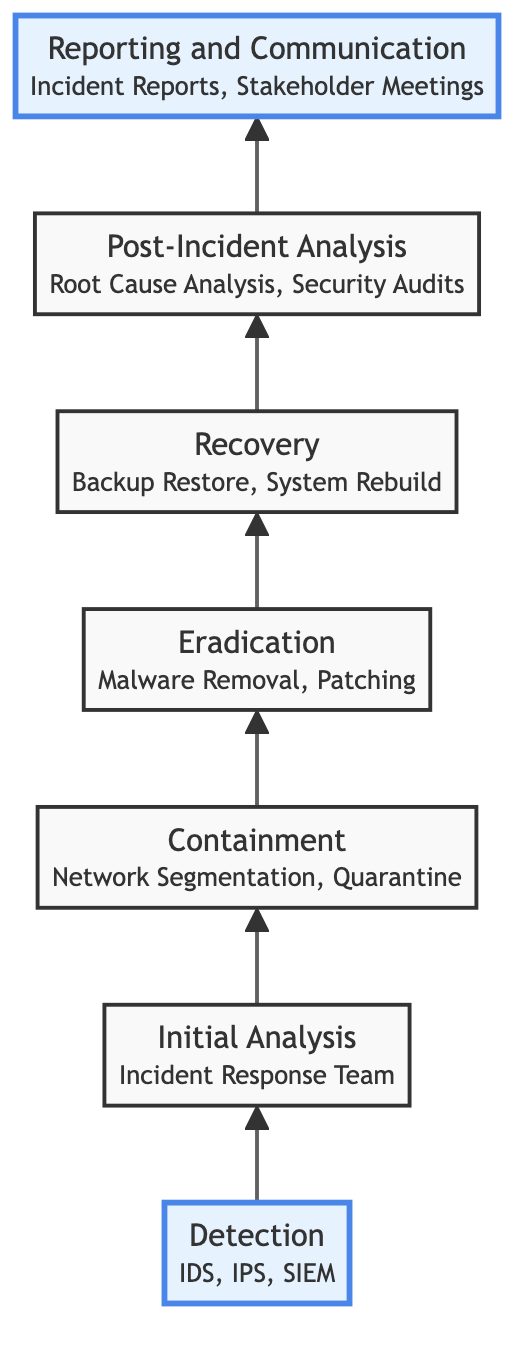What is the first step in the cyber attack investigation process? The diagram indicates that the first step is "Detection," which is the initial phase of identifying suspicious activities.
Answer: Detection How many main steps are shown in the diagram? By counting the elements listed in the diagram, there are seven main steps in total from Detection to Reporting and Communication.
Answer: Seven Which entity is associated with the "Initial Analysis" step? The node for "Initial Analysis" explicitly mentions the "Incident Response Team" as the associated entity responsible for this step.
Answer: Incident Response Team What comes immediately after "Containment" in the flow of the investigation? Following the "Containment" step, the next step in the sequence according to the diagram is "Eradication."
Answer: Eradication What is the last step in the investigation process? The last step in the diagram is "Reporting and Communication," which documents and communicates the findings to stakeholders.
Answer: Reporting and Communication Identify the step that involves restoring systems and data. The "Recovery" step is specifically focused on restoring systems and data from clean backups and resuming normal operations.
Answer: Recovery What actions are encompassed in the "Eradication" step? The diagram lists "Malware Removal Tools" and "Patching Vulnerabilities" as key actions carried out during the "Eradication" step to remove the root cause of the attack.
Answer: Malware Removal Tools, Patching Vulnerabilities Which step involves a review to improve security measures? The "Post-Incident Analysis" step involves reviewing the incident to identify weaknesses and enhance future security measures.
Answer: Post-Incident Analysis What is the relationship between "Detection" and "Recovery"? "Detection" is the first step that initiates the investigation process, while "Recovery" is further down the flow, indicating that it occurs later after several intervening steps have been completed.
Answer: Detection initiates the process; Recovery is a later step 